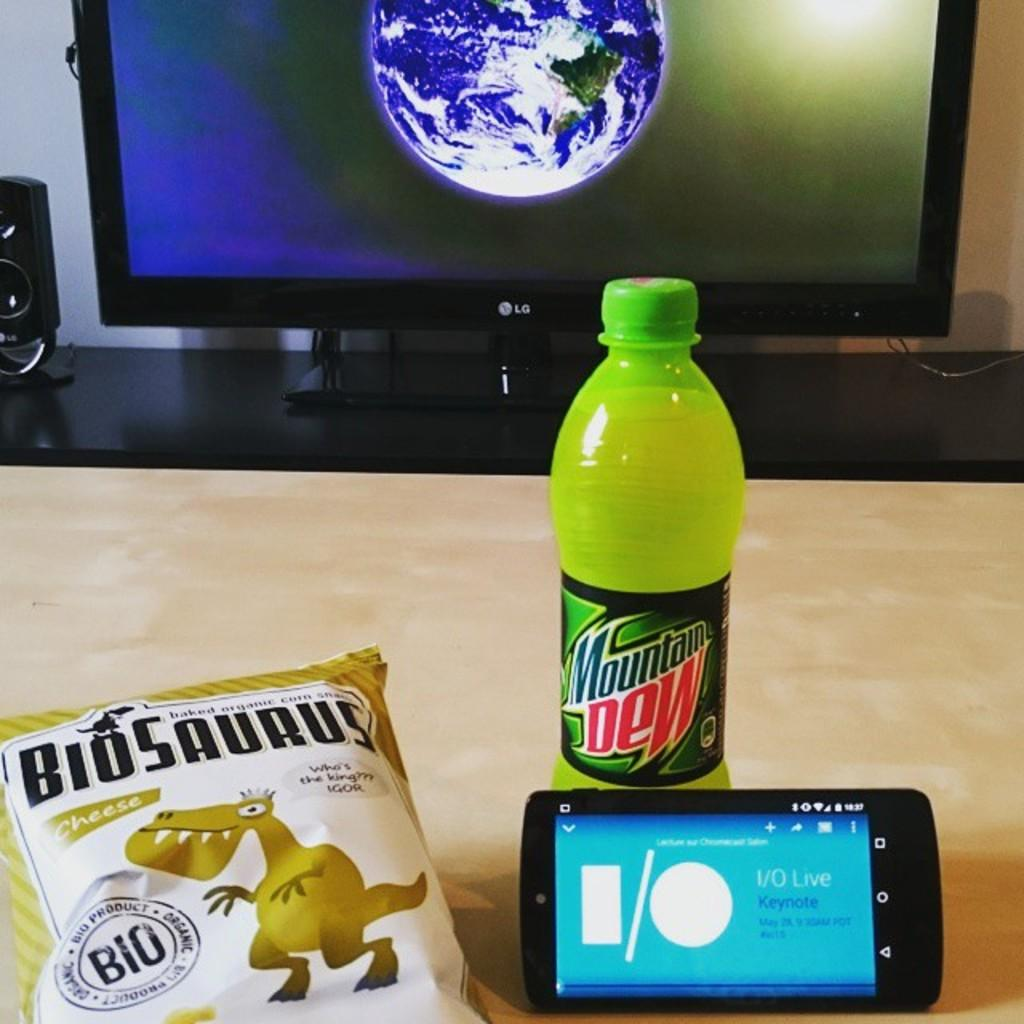<image>
Provide a brief description of the given image. a soda that has the title of Mountain Dew on it 